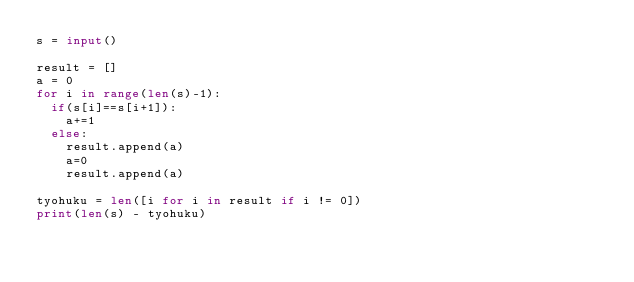<code> <loc_0><loc_0><loc_500><loc_500><_Python_>s = input()

result = []
a = 0
for i in range(len(s)-1):
  if(s[i]==s[i+1]):
    a+=1
  else:
    result.append(a)
    a=0
    result.append(a)

tyohuku = len([i for i in result if i != 0])
print(len(s) - tyohuku)
</code> 